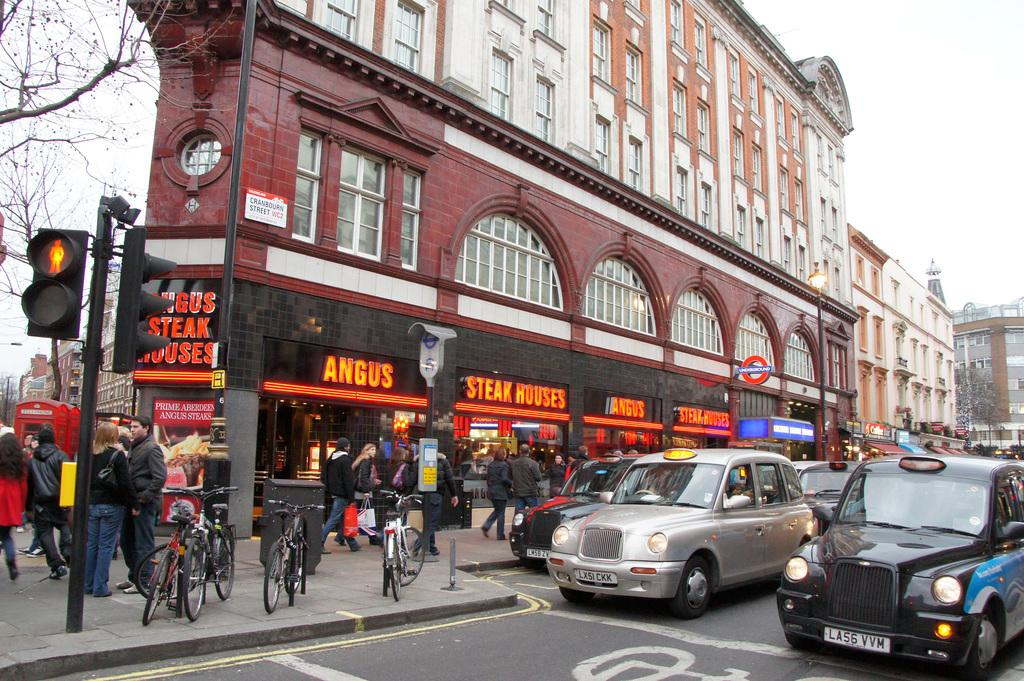<image>
Present a compact description of the photo's key features. The restaurant with the words Angus Steak Houses above the entrance. 